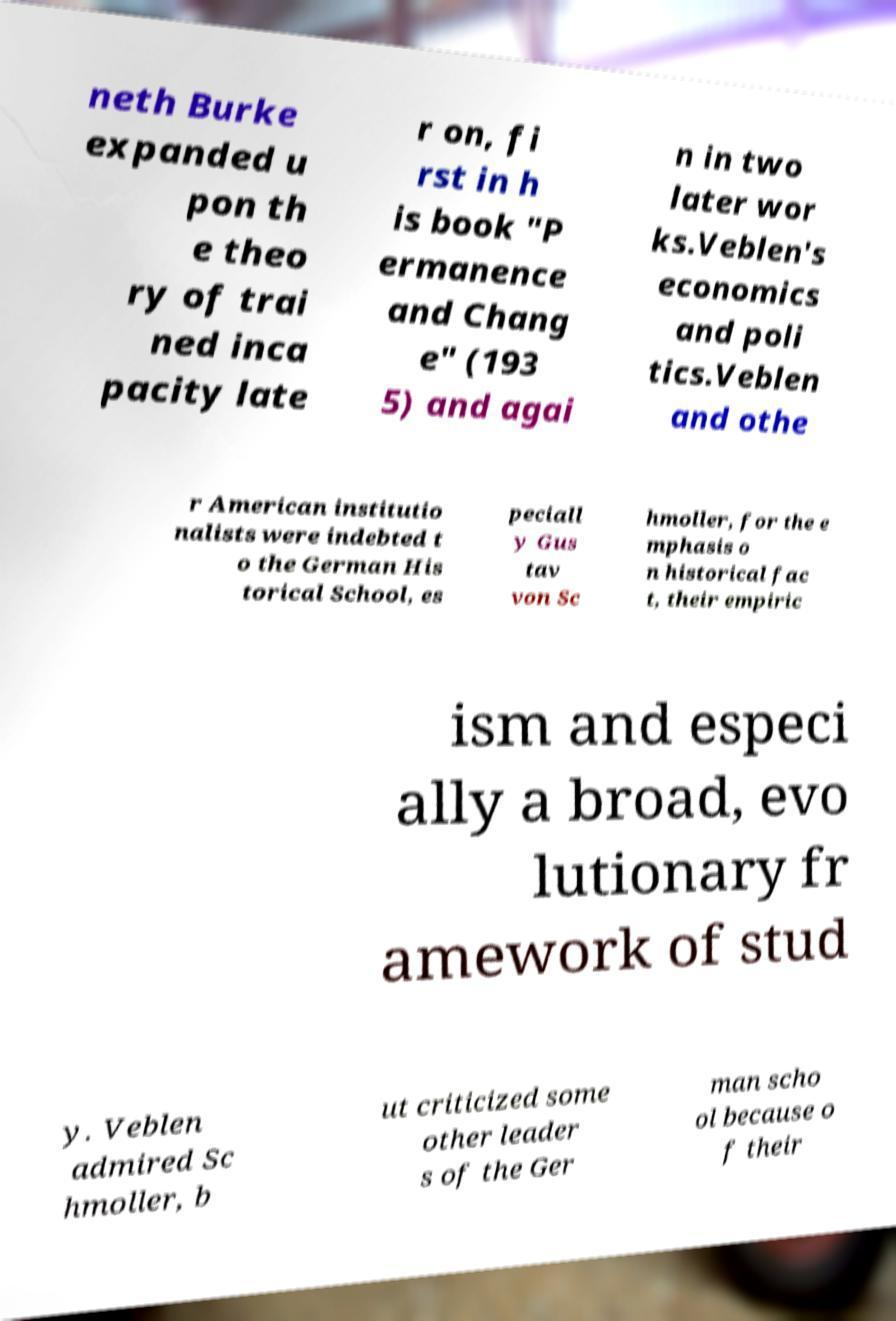I need the written content from this picture converted into text. Can you do that? neth Burke expanded u pon th e theo ry of trai ned inca pacity late r on, fi rst in h is book "P ermanence and Chang e" (193 5) and agai n in two later wor ks.Veblen's economics and poli tics.Veblen and othe r American institutio nalists were indebted t o the German His torical School, es peciall y Gus tav von Sc hmoller, for the e mphasis o n historical fac t, their empiric ism and especi ally a broad, evo lutionary fr amework of stud y. Veblen admired Sc hmoller, b ut criticized some other leader s of the Ger man scho ol because o f their 